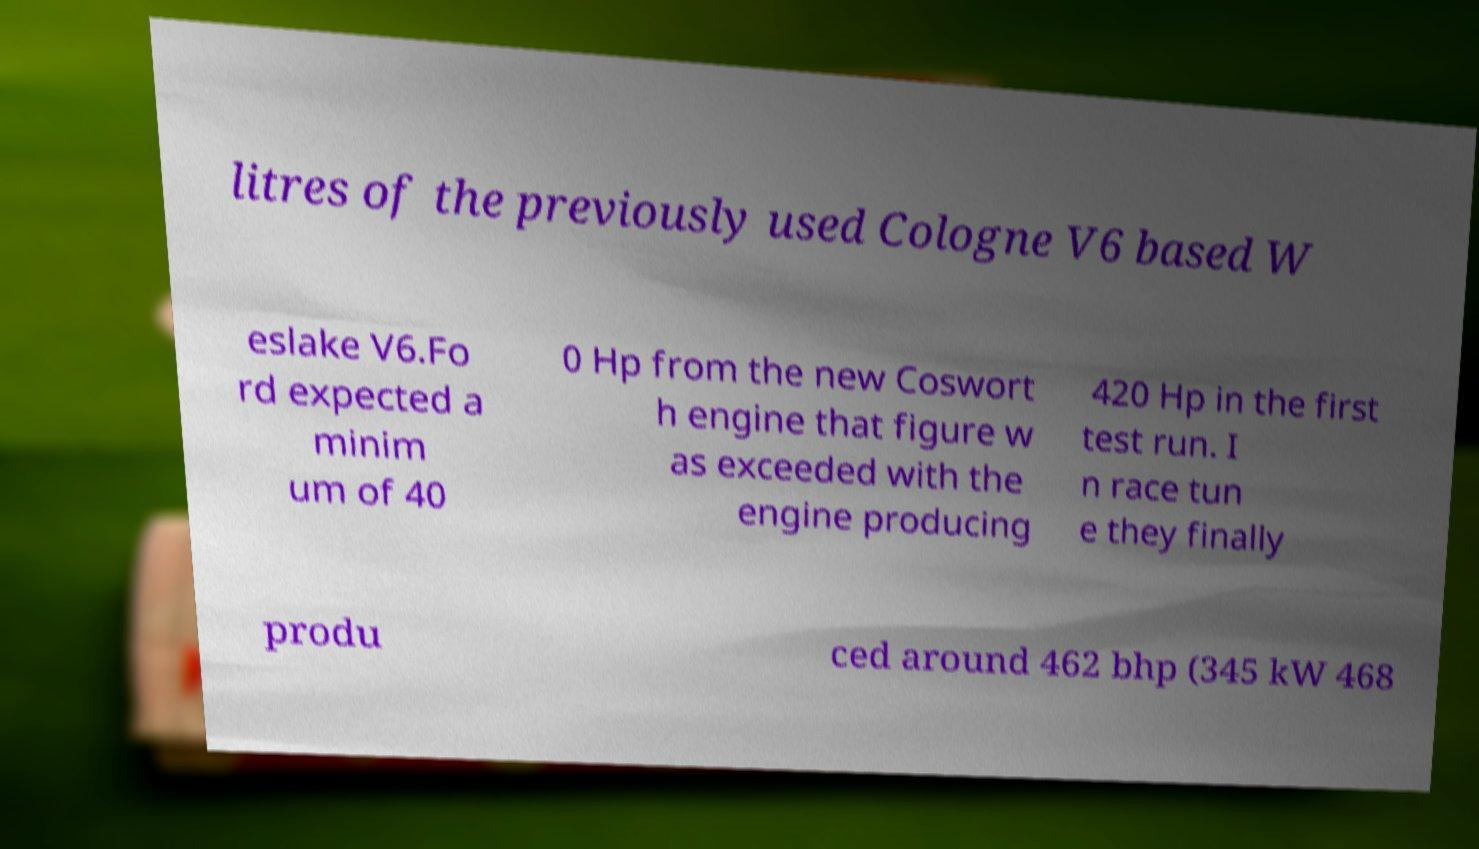Can you accurately transcribe the text from the provided image for me? litres of the previously used Cologne V6 based W eslake V6.Fo rd expected a minim um of 40 0 Hp from the new Coswort h engine that figure w as exceeded with the engine producing 420 Hp in the first test run. I n race tun e they finally produ ced around 462 bhp (345 kW 468 